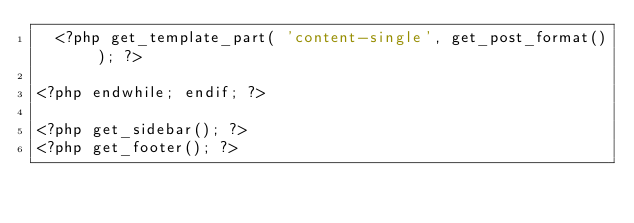Convert code to text. <code><loc_0><loc_0><loc_500><loc_500><_PHP_>	<?php get_template_part( 'content-single', get_post_format() ); ?>

<?php endwhile; endif; ?>

<?php get_sidebar(); ?>
<?php get_footer(); ?>
</code> 